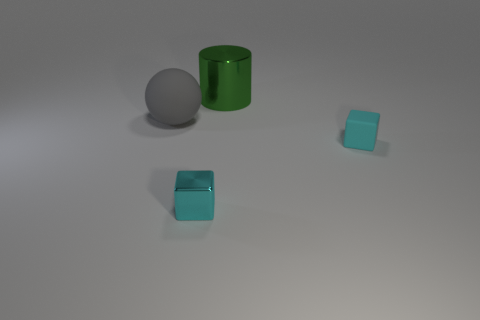There is a thing that is the same color as the tiny matte block; what is its shape?
Offer a terse response. Cube. What is the material of the other tiny block that is the same color as the shiny cube?
Keep it short and to the point. Rubber. Are there any other metal objects that have the same shape as the tiny metal object?
Provide a short and direct response. No. There is a large object that is behind the large gray sphere; is its shape the same as the small cyan object behind the cyan metallic object?
Offer a terse response. No. Is there another thing that has the same size as the green object?
Your response must be concise. Yes. Is the number of gray rubber balls on the right side of the small cyan metal object the same as the number of large green metallic objects behind the cyan rubber block?
Give a very brief answer. No. Is the thing behind the rubber sphere made of the same material as the cyan thing to the left of the matte cube?
Your answer should be very brief. Yes. What material is the green object?
Offer a terse response. Metal. What number of other things are the same color as the large rubber thing?
Offer a terse response. 0. Do the matte sphere and the matte block have the same color?
Give a very brief answer. No. 